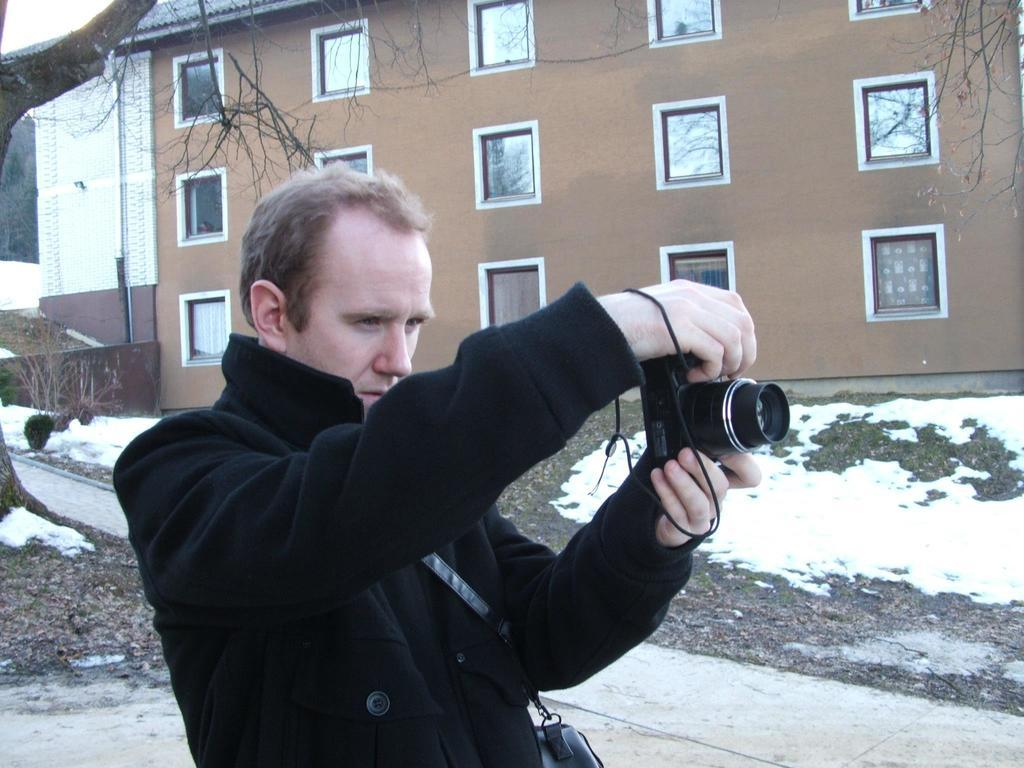What is the person in the image doing? The person is holding a camera in the image. What is the person wearing in the image? The person is wearing a black coat in the image. What else is the person holding in the image? The person is holding a bag in the image. What can be seen in the background of the image? There is a building in the background of the image. How would you describe the weather in the image? The background of the image is cloudy, suggesting a potentially overcast or cloudy day. What type of jewel can be seen on the person's hand in the image? There is no jewel visible on the person's hand in the image. How many roses are present in the image? There are no roses present in the image. 